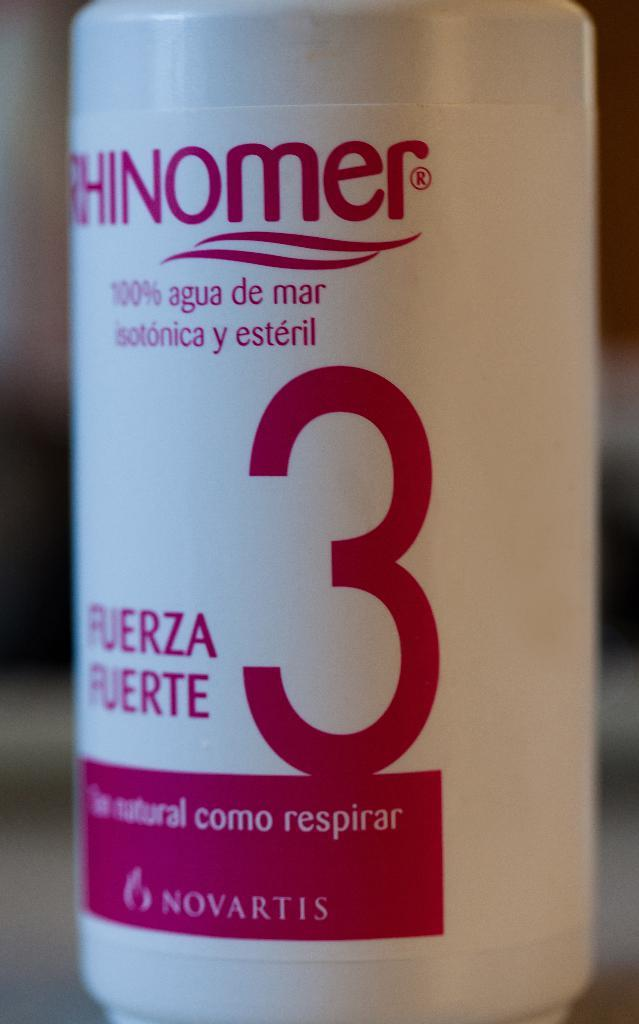What object can be seen in the image? There is a bottle in the image. What is the color of the bottle? The bottle is white in color. What type of bottle does it resemble? The bottle resembles a cream bottle. Can you describe the background of the image? The background of the image is blurred. Is there a leather agreement visible in the image? No, there is no leather agreement present in the image. 